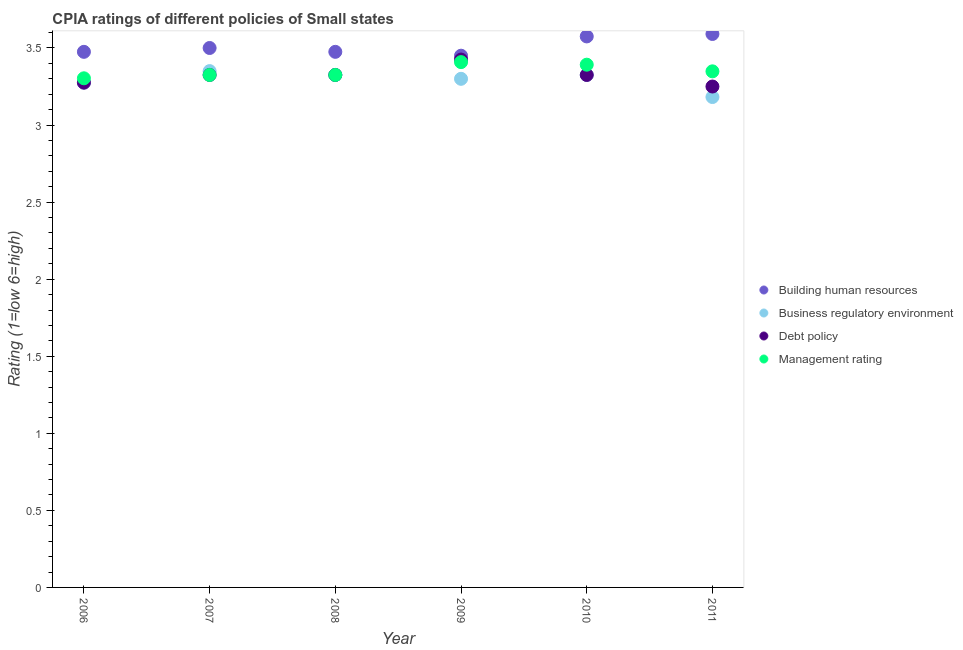How many different coloured dotlines are there?
Ensure brevity in your answer.  4. Across all years, what is the maximum cpia rating of building human resources?
Your answer should be very brief. 3.59. In which year was the cpia rating of business regulatory environment minimum?
Provide a short and direct response. 2011. What is the total cpia rating of debt policy in the graph?
Keep it short and to the point. 19.93. What is the difference between the cpia rating of debt policy in 2007 and that in 2011?
Provide a succinct answer. 0.08. What is the difference between the cpia rating of debt policy in 2010 and the cpia rating of management in 2006?
Give a very brief answer. 0.02. What is the average cpia rating of debt policy per year?
Keep it short and to the point. 3.32. In the year 2011, what is the difference between the cpia rating of business regulatory environment and cpia rating of management?
Keep it short and to the point. -0.17. What is the ratio of the cpia rating of debt policy in 2007 to that in 2011?
Your response must be concise. 1.02. Is the cpia rating of business regulatory environment in 2008 less than that in 2011?
Your answer should be very brief. No. Is the difference between the cpia rating of building human resources in 2009 and 2010 greater than the difference between the cpia rating of management in 2009 and 2010?
Make the answer very short. No. What is the difference between the highest and the second highest cpia rating of business regulatory environment?
Your response must be concise. 0.02. What is the difference between the highest and the lowest cpia rating of business regulatory environment?
Give a very brief answer. 0.17. Is it the case that in every year, the sum of the cpia rating of building human resources and cpia rating of debt policy is greater than the sum of cpia rating of business regulatory environment and cpia rating of management?
Ensure brevity in your answer.  No. Is it the case that in every year, the sum of the cpia rating of building human resources and cpia rating of business regulatory environment is greater than the cpia rating of debt policy?
Your response must be concise. Yes. Is the cpia rating of business regulatory environment strictly greater than the cpia rating of management over the years?
Provide a succinct answer. No. Is the cpia rating of building human resources strictly less than the cpia rating of management over the years?
Provide a succinct answer. No. Are the values on the major ticks of Y-axis written in scientific E-notation?
Your answer should be very brief. No. Does the graph contain any zero values?
Your answer should be very brief. No. How many legend labels are there?
Your answer should be compact. 4. How are the legend labels stacked?
Offer a terse response. Vertical. What is the title of the graph?
Ensure brevity in your answer.  CPIA ratings of different policies of Small states. Does "Secondary vocational education" appear as one of the legend labels in the graph?
Your response must be concise. No. What is the Rating (1=low 6=high) of Building human resources in 2006?
Ensure brevity in your answer.  3.48. What is the Rating (1=low 6=high) of Business regulatory environment in 2006?
Your answer should be compact. 3.27. What is the Rating (1=low 6=high) of Debt policy in 2006?
Your response must be concise. 3.27. What is the Rating (1=low 6=high) in Management rating in 2006?
Give a very brief answer. 3.3. What is the Rating (1=low 6=high) of Building human resources in 2007?
Offer a very short reply. 3.5. What is the Rating (1=low 6=high) of Business regulatory environment in 2007?
Ensure brevity in your answer.  3.35. What is the Rating (1=low 6=high) in Debt policy in 2007?
Your answer should be compact. 3.33. What is the Rating (1=low 6=high) of Management rating in 2007?
Make the answer very short. 3.33. What is the Rating (1=low 6=high) of Building human resources in 2008?
Make the answer very short. 3.48. What is the Rating (1=low 6=high) of Business regulatory environment in 2008?
Make the answer very short. 3.33. What is the Rating (1=low 6=high) of Debt policy in 2008?
Keep it short and to the point. 3.33. What is the Rating (1=low 6=high) of Management rating in 2008?
Your answer should be compact. 3.33. What is the Rating (1=low 6=high) in Building human resources in 2009?
Offer a very short reply. 3.45. What is the Rating (1=low 6=high) of Debt policy in 2009?
Offer a terse response. 3.42. What is the Rating (1=low 6=high) in Management rating in 2009?
Ensure brevity in your answer.  3.41. What is the Rating (1=low 6=high) of Building human resources in 2010?
Your answer should be very brief. 3.58. What is the Rating (1=low 6=high) of Business regulatory environment in 2010?
Keep it short and to the point. 3.33. What is the Rating (1=low 6=high) in Debt policy in 2010?
Your response must be concise. 3.33. What is the Rating (1=low 6=high) of Management rating in 2010?
Your answer should be compact. 3.39. What is the Rating (1=low 6=high) in Building human resources in 2011?
Ensure brevity in your answer.  3.59. What is the Rating (1=low 6=high) in Business regulatory environment in 2011?
Your answer should be very brief. 3.18. What is the Rating (1=low 6=high) of Debt policy in 2011?
Offer a terse response. 3.25. What is the Rating (1=low 6=high) in Management rating in 2011?
Keep it short and to the point. 3.35. Across all years, what is the maximum Rating (1=low 6=high) in Building human resources?
Provide a succinct answer. 3.59. Across all years, what is the maximum Rating (1=low 6=high) of Business regulatory environment?
Make the answer very short. 3.35. Across all years, what is the maximum Rating (1=low 6=high) in Debt policy?
Offer a terse response. 3.42. Across all years, what is the maximum Rating (1=low 6=high) of Management rating?
Provide a succinct answer. 3.41. Across all years, what is the minimum Rating (1=low 6=high) of Building human resources?
Make the answer very short. 3.45. Across all years, what is the minimum Rating (1=low 6=high) in Business regulatory environment?
Ensure brevity in your answer.  3.18. Across all years, what is the minimum Rating (1=low 6=high) in Debt policy?
Provide a succinct answer. 3.25. Across all years, what is the minimum Rating (1=low 6=high) in Management rating?
Keep it short and to the point. 3.3. What is the total Rating (1=low 6=high) of Building human resources in the graph?
Offer a very short reply. 21.07. What is the total Rating (1=low 6=high) of Business regulatory environment in the graph?
Keep it short and to the point. 19.76. What is the total Rating (1=low 6=high) in Debt policy in the graph?
Make the answer very short. 19.93. What is the total Rating (1=low 6=high) in Management rating in the graph?
Provide a short and direct response. 20.1. What is the difference between the Rating (1=low 6=high) in Building human resources in 2006 and that in 2007?
Provide a succinct answer. -0.03. What is the difference between the Rating (1=low 6=high) in Business regulatory environment in 2006 and that in 2007?
Give a very brief answer. -0.07. What is the difference between the Rating (1=low 6=high) of Management rating in 2006 and that in 2007?
Your answer should be compact. -0.02. What is the difference between the Rating (1=low 6=high) in Building human resources in 2006 and that in 2008?
Make the answer very short. 0. What is the difference between the Rating (1=low 6=high) of Debt policy in 2006 and that in 2008?
Offer a very short reply. -0.05. What is the difference between the Rating (1=low 6=high) in Management rating in 2006 and that in 2008?
Your response must be concise. -0.02. What is the difference between the Rating (1=low 6=high) of Building human resources in 2006 and that in 2009?
Keep it short and to the point. 0.03. What is the difference between the Rating (1=low 6=high) of Business regulatory environment in 2006 and that in 2009?
Give a very brief answer. -0.03. What is the difference between the Rating (1=low 6=high) in Management rating in 2006 and that in 2009?
Give a very brief answer. -0.1. What is the difference between the Rating (1=low 6=high) of Building human resources in 2006 and that in 2010?
Offer a terse response. -0.1. What is the difference between the Rating (1=low 6=high) in Business regulatory environment in 2006 and that in 2010?
Offer a very short reply. -0.05. What is the difference between the Rating (1=low 6=high) of Debt policy in 2006 and that in 2010?
Ensure brevity in your answer.  -0.05. What is the difference between the Rating (1=low 6=high) in Management rating in 2006 and that in 2010?
Offer a terse response. -0.09. What is the difference between the Rating (1=low 6=high) in Building human resources in 2006 and that in 2011?
Keep it short and to the point. -0.12. What is the difference between the Rating (1=low 6=high) of Business regulatory environment in 2006 and that in 2011?
Offer a very short reply. 0.09. What is the difference between the Rating (1=low 6=high) of Debt policy in 2006 and that in 2011?
Your answer should be very brief. 0.03. What is the difference between the Rating (1=low 6=high) in Management rating in 2006 and that in 2011?
Ensure brevity in your answer.  -0.05. What is the difference between the Rating (1=low 6=high) in Building human resources in 2007 and that in 2008?
Give a very brief answer. 0.03. What is the difference between the Rating (1=low 6=high) of Business regulatory environment in 2007 and that in 2008?
Keep it short and to the point. 0.03. What is the difference between the Rating (1=low 6=high) in Debt policy in 2007 and that in 2008?
Your answer should be very brief. 0. What is the difference between the Rating (1=low 6=high) of Business regulatory environment in 2007 and that in 2009?
Ensure brevity in your answer.  0.05. What is the difference between the Rating (1=low 6=high) of Management rating in 2007 and that in 2009?
Make the answer very short. -0.08. What is the difference between the Rating (1=low 6=high) of Building human resources in 2007 and that in 2010?
Offer a terse response. -0.07. What is the difference between the Rating (1=low 6=high) in Business regulatory environment in 2007 and that in 2010?
Make the answer very short. 0.03. What is the difference between the Rating (1=low 6=high) of Debt policy in 2007 and that in 2010?
Provide a short and direct response. 0. What is the difference between the Rating (1=low 6=high) of Management rating in 2007 and that in 2010?
Ensure brevity in your answer.  -0.07. What is the difference between the Rating (1=low 6=high) of Building human resources in 2007 and that in 2011?
Make the answer very short. -0.09. What is the difference between the Rating (1=low 6=high) of Business regulatory environment in 2007 and that in 2011?
Give a very brief answer. 0.17. What is the difference between the Rating (1=low 6=high) in Debt policy in 2007 and that in 2011?
Your answer should be compact. 0.07. What is the difference between the Rating (1=low 6=high) in Management rating in 2007 and that in 2011?
Make the answer very short. -0.02. What is the difference between the Rating (1=low 6=high) of Building human resources in 2008 and that in 2009?
Offer a terse response. 0.03. What is the difference between the Rating (1=low 6=high) in Business regulatory environment in 2008 and that in 2009?
Your response must be concise. 0.03. What is the difference between the Rating (1=low 6=high) of Management rating in 2008 and that in 2009?
Keep it short and to the point. -0.08. What is the difference between the Rating (1=low 6=high) in Business regulatory environment in 2008 and that in 2010?
Your response must be concise. 0. What is the difference between the Rating (1=low 6=high) of Debt policy in 2008 and that in 2010?
Offer a very short reply. 0. What is the difference between the Rating (1=low 6=high) in Management rating in 2008 and that in 2010?
Offer a terse response. -0.07. What is the difference between the Rating (1=low 6=high) of Building human resources in 2008 and that in 2011?
Ensure brevity in your answer.  -0.12. What is the difference between the Rating (1=low 6=high) in Business regulatory environment in 2008 and that in 2011?
Keep it short and to the point. 0.14. What is the difference between the Rating (1=low 6=high) in Debt policy in 2008 and that in 2011?
Your answer should be very brief. 0.07. What is the difference between the Rating (1=low 6=high) in Management rating in 2008 and that in 2011?
Make the answer very short. -0.02. What is the difference between the Rating (1=low 6=high) in Building human resources in 2009 and that in 2010?
Your response must be concise. -0.12. What is the difference between the Rating (1=low 6=high) of Business regulatory environment in 2009 and that in 2010?
Give a very brief answer. -0.03. What is the difference between the Rating (1=low 6=high) in Debt policy in 2009 and that in 2010?
Provide a short and direct response. 0.1. What is the difference between the Rating (1=low 6=high) of Management rating in 2009 and that in 2010?
Provide a succinct answer. 0.02. What is the difference between the Rating (1=low 6=high) in Building human resources in 2009 and that in 2011?
Your answer should be very brief. -0.14. What is the difference between the Rating (1=low 6=high) of Business regulatory environment in 2009 and that in 2011?
Provide a short and direct response. 0.12. What is the difference between the Rating (1=low 6=high) of Debt policy in 2009 and that in 2011?
Make the answer very short. 0.17. What is the difference between the Rating (1=low 6=high) in Management rating in 2009 and that in 2011?
Ensure brevity in your answer.  0.06. What is the difference between the Rating (1=low 6=high) of Building human resources in 2010 and that in 2011?
Offer a very short reply. -0.02. What is the difference between the Rating (1=low 6=high) of Business regulatory environment in 2010 and that in 2011?
Make the answer very short. 0.14. What is the difference between the Rating (1=low 6=high) of Debt policy in 2010 and that in 2011?
Give a very brief answer. 0.07. What is the difference between the Rating (1=low 6=high) in Management rating in 2010 and that in 2011?
Your answer should be very brief. 0.04. What is the difference between the Rating (1=low 6=high) of Building human resources in 2006 and the Rating (1=low 6=high) of Debt policy in 2007?
Provide a succinct answer. 0.15. What is the difference between the Rating (1=low 6=high) of Business regulatory environment in 2006 and the Rating (1=low 6=high) of Debt policy in 2007?
Your answer should be compact. -0.05. What is the difference between the Rating (1=low 6=high) of Business regulatory environment in 2006 and the Rating (1=low 6=high) of Management rating in 2007?
Provide a short and direct response. -0.05. What is the difference between the Rating (1=low 6=high) in Building human resources in 2006 and the Rating (1=low 6=high) in Debt policy in 2008?
Give a very brief answer. 0.15. What is the difference between the Rating (1=low 6=high) in Business regulatory environment in 2006 and the Rating (1=low 6=high) in Debt policy in 2008?
Your response must be concise. -0.05. What is the difference between the Rating (1=low 6=high) in Business regulatory environment in 2006 and the Rating (1=low 6=high) in Management rating in 2008?
Offer a terse response. -0.05. What is the difference between the Rating (1=low 6=high) of Building human resources in 2006 and the Rating (1=low 6=high) of Business regulatory environment in 2009?
Offer a very short reply. 0.17. What is the difference between the Rating (1=low 6=high) in Building human resources in 2006 and the Rating (1=low 6=high) in Management rating in 2009?
Keep it short and to the point. 0.07. What is the difference between the Rating (1=low 6=high) of Business regulatory environment in 2006 and the Rating (1=low 6=high) of Management rating in 2009?
Your answer should be very brief. -0.13. What is the difference between the Rating (1=low 6=high) of Debt policy in 2006 and the Rating (1=low 6=high) of Management rating in 2009?
Provide a short and direct response. -0.13. What is the difference between the Rating (1=low 6=high) of Building human resources in 2006 and the Rating (1=low 6=high) of Management rating in 2010?
Keep it short and to the point. 0.08. What is the difference between the Rating (1=low 6=high) in Business regulatory environment in 2006 and the Rating (1=low 6=high) in Management rating in 2010?
Your answer should be compact. -0.12. What is the difference between the Rating (1=low 6=high) in Debt policy in 2006 and the Rating (1=low 6=high) in Management rating in 2010?
Give a very brief answer. -0.12. What is the difference between the Rating (1=low 6=high) of Building human resources in 2006 and the Rating (1=low 6=high) of Business regulatory environment in 2011?
Give a very brief answer. 0.29. What is the difference between the Rating (1=low 6=high) of Building human resources in 2006 and the Rating (1=low 6=high) of Debt policy in 2011?
Your answer should be very brief. 0.23. What is the difference between the Rating (1=low 6=high) of Building human resources in 2006 and the Rating (1=low 6=high) of Management rating in 2011?
Offer a terse response. 0.13. What is the difference between the Rating (1=low 6=high) of Business regulatory environment in 2006 and the Rating (1=low 6=high) of Debt policy in 2011?
Provide a short and direct response. 0.03. What is the difference between the Rating (1=low 6=high) of Business regulatory environment in 2006 and the Rating (1=low 6=high) of Management rating in 2011?
Offer a very short reply. -0.07. What is the difference between the Rating (1=low 6=high) in Debt policy in 2006 and the Rating (1=low 6=high) in Management rating in 2011?
Provide a short and direct response. -0.07. What is the difference between the Rating (1=low 6=high) of Building human resources in 2007 and the Rating (1=low 6=high) of Business regulatory environment in 2008?
Offer a terse response. 0.17. What is the difference between the Rating (1=low 6=high) of Building human resources in 2007 and the Rating (1=low 6=high) of Debt policy in 2008?
Ensure brevity in your answer.  0.17. What is the difference between the Rating (1=low 6=high) in Building human resources in 2007 and the Rating (1=low 6=high) in Management rating in 2008?
Keep it short and to the point. 0.17. What is the difference between the Rating (1=low 6=high) in Business regulatory environment in 2007 and the Rating (1=low 6=high) in Debt policy in 2008?
Provide a succinct answer. 0.03. What is the difference between the Rating (1=low 6=high) in Business regulatory environment in 2007 and the Rating (1=low 6=high) in Management rating in 2008?
Your answer should be very brief. 0.03. What is the difference between the Rating (1=low 6=high) in Building human resources in 2007 and the Rating (1=low 6=high) in Business regulatory environment in 2009?
Offer a very short reply. 0.2. What is the difference between the Rating (1=low 6=high) of Building human resources in 2007 and the Rating (1=low 6=high) of Debt policy in 2009?
Offer a terse response. 0.07. What is the difference between the Rating (1=low 6=high) of Building human resources in 2007 and the Rating (1=low 6=high) of Management rating in 2009?
Offer a very short reply. 0.09. What is the difference between the Rating (1=low 6=high) in Business regulatory environment in 2007 and the Rating (1=low 6=high) in Debt policy in 2009?
Give a very brief answer. -0.07. What is the difference between the Rating (1=low 6=high) of Business regulatory environment in 2007 and the Rating (1=low 6=high) of Management rating in 2009?
Provide a succinct answer. -0.06. What is the difference between the Rating (1=low 6=high) in Debt policy in 2007 and the Rating (1=low 6=high) in Management rating in 2009?
Provide a short and direct response. -0.08. What is the difference between the Rating (1=low 6=high) of Building human resources in 2007 and the Rating (1=low 6=high) of Business regulatory environment in 2010?
Keep it short and to the point. 0.17. What is the difference between the Rating (1=low 6=high) of Building human resources in 2007 and the Rating (1=low 6=high) of Debt policy in 2010?
Your answer should be very brief. 0.17. What is the difference between the Rating (1=low 6=high) in Building human resources in 2007 and the Rating (1=low 6=high) in Management rating in 2010?
Provide a succinct answer. 0.11. What is the difference between the Rating (1=low 6=high) in Business regulatory environment in 2007 and the Rating (1=low 6=high) in Debt policy in 2010?
Provide a short and direct response. 0.03. What is the difference between the Rating (1=low 6=high) in Business regulatory environment in 2007 and the Rating (1=low 6=high) in Management rating in 2010?
Offer a terse response. -0.04. What is the difference between the Rating (1=low 6=high) in Debt policy in 2007 and the Rating (1=low 6=high) in Management rating in 2010?
Ensure brevity in your answer.  -0.07. What is the difference between the Rating (1=low 6=high) of Building human resources in 2007 and the Rating (1=low 6=high) of Business regulatory environment in 2011?
Your answer should be very brief. 0.32. What is the difference between the Rating (1=low 6=high) in Building human resources in 2007 and the Rating (1=low 6=high) in Management rating in 2011?
Keep it short and to the point. 0.15. What is the difference between the Rating (1=low 6=high) of Business regulatory environment in 2007 and the Rating (1=low 6=high) of Debt policy in 2011?
Give a very brief answer. 0.1. What is the difference between the Rating (1=low 6=high) of Business regulatory environment in 2007 and the Rating (1=low 6=high) of Management rating in 2011?
Your answer should be very brief. 0. What is the difference between the Rating (1=low 6=high) of Debt policy in 2007 and the Rating (1=low 6=high) of Management rating in 2011?
Provide a short and direct response. -0.02. What is the difference between the Rating (1=low 6=high) in Building human resources in 2008 and the Rating (1=low 6=high) in Business regulatory environment in 2009?
Keep it short and to the point. 0.17. What is the difference between the Rating (1=low 6=high) of Building human resources in 2008 and the Rating (1=low 6=high) of Debt policy in 2009?
Offer a terse response. 0.05. What is the difference between the Rating (1=low 6=high) in Building human resources in 2008 and the Rating (1=low 6=high) in Management rating in 2009?
Offer a very short reply. 0.07. What is the difference between the Rating (1=low 6=high) in Business regulatory environment in 2008 and the Rating (1=low 6=high) in Management rating in 2009?
Ensure brevity in your answer.  -0.08. What is the difference between the Rating (1=low 6=high) in Debt policy in 2008 and the Rating (1=low 6=high) in Management rating in 2009?
Your response must be concise. -0.08. What is the difference between the Rating (1=low 6=high) of Building human resources in 2008 and the Rating (1=low 6=high) of Business regulatory environment in 2010?
Provide a short and direct response. 0.15. What is the difference between the Rating (1=low 6=high) of Building human resources in 2008 and the Rating (1=low 6=high) of Debt policy in 2010?
Provide a short and direct response. 0.15. What is the difference between the Rating (1=low 6=high) of Building human resources in 2008 and the Rating (1=low 6=high) of Management rating in 2010?
Provide a short and direct response. 0.08. What is the difference between the Rating (1=low 6=high) of Business regulatory environment in 2008 and the Rating (1=low 6=high) of Debt policy in 2010?
Keep it short and to the point. 0. What is the difference between the Rating (1=low 6=high) in Business regulatory environment in 2008 and the Rating (1=low 6=high) in Management rating in 2010?
Give a very brief answer. -0.07. What is the difference between the Rating (1=low 6=high) of Debt policy in 2008 and the Rating (1=low 6=high) of Management rating in 2010?
Give a very brief answer. -0.07. What is the difference between the Rating (1=low 6=high) in Building human resources in 2008 and the Rating (1=low 6=high) in Business regulatory environment in 2011?
Offer a terse response. 0.29. What is the difference between the Rating (1=low 6=high) of Building human resources in 2008 and the Rating (1=low 6=high) of Debt policy in 2011?
Ensure brevity in your answer.  0.23. What is the difference between the Rating (1=low 6=high) of Building human resources in 2008 and the Rating (1=low 6=high) of Management rating in 2011?
Your answer should be compact. 0.13. What is the difference between the Rating (1=low 6=high) of Business regulatory environment in 2008 and the Rating (1=low 6=high) of Debt policy in 2011?
Provide a short and direct response. 0.07. What is the difference between the Rating (1=low 6=high) of Business regulatory environment in 2008 and the Rating (1=low 6=high) of Management rating in 2011?
Make the answer very short. -0.02. What is the difference between the Rating (1=low 6=high) of Debt policy in 2008 and the Rating (1=low 6=high) of Management rating in 2011?
Your answer should be compact. -0.02. What is the difference between the Rating (1=low 6=high) of Building human resources in 2009 and the Rating (1=low 6=high) of Debt policy in 2010?
Your response must be concise. 0.12. What is the difference between the Rating (1=low 6=high) in Building human resources in 2009 and the Rating (1=low 6=high) in Management rating in 2010?
Your answer should be very brief. 0.06. What is the difference between the Rating (1=low 6=high) of Business regulatory environment in 2009 and the Rating (1=low 6=high) of Debt policy in 2010?
Ensure brevity in your answer.  -0.03. What is the difference between the Rating (1=low 6=high) of Business regulatory environment in 2009 and the Rating (1=low 6=high) of Management rating in 2010?
Your response must be concise. -0.09. What is the difference between the Rating (1=low 6=high) in Debt policy in 2009 and the Rating (1=low 6=high) in Management rating in 2010?
Provide a succinct answer. 0.03. What is the difference between the Rating (1=low 6=high) of Building human resources in 2009 and the Rating (1=low 6=high) of Business regulatory environment in 2011?
Provide a succinct answer. 0.27. What is the difference between the Rating (1=low 6=high) of Building human resources in 2009 and the Rating (1=low 6=high) of Debt policy in 2011?
Give a very brief answer. 0.2. What is the difference between the Rating (1=low 6=high) in Building human resources in 2009 and the Rating (1=low 6=high) in Management rating in 2011?
Offer a very short reply. 0.1. What is the difference between the Rating (1=low 6=high) of Business regulatory environment in 2009 and the Rating (1=low 6=high) of Management rating in 2011?
Make the answer very short. -0.05. What is the difference between the Rating (1=low 6=high) of Debt policy in 2009 and the Rating (1=low 6=high) of Management rating in 2011?
Ensure brevity in your answer.  0.08. What is the difference between the Rating (1=low 6=high) in Building human resources in 2010 and the Rating (1=low 6=high) in Business regulatory environment in 2011?
Provide a succinct answer. 0.39. What is the difference between the Rating (1=low 6=high) in Building human resources in 2010 and the Rating (1=low 6=high) in Debt policy in 2011?
Ensure brevity in your answer.  0.33. What is the difference between the Rating (1=low 6=high) in Building human resources in 2010 and the Rating (1=low 6=high) in Management rating in 2011?
Offer a very short reply. 0.23. What is the difference between the Rating (1=low 6=high) in Business regulatory environment in 2010 and the Rating (1=low 6=high) in Debt policy in 2011?
Give a very brief answer. 0.07. What is the difference between the Rating (1=low 6=high) of Business regulatory environment in 2010 and the Rating (1=low 6=high) of Management rating in 2011?
Your response must be concise. -0.02. What is the difference between the Rating (1=low 6=high) of Debt policy in 2010 and the Rating (1=low 6=high) of Management rating in 2011?
Provide a succinct answer. -0.02. What is the average Rating (1=low 6=high) in Building human resources per year?
Offer a very short reply. 3.51. What is the average Rating (1=low 6=high) of Business regulatory environment per year?
Make the answer very short. 3.29. What is the average Rating (1=low 6=high) of Debt policy per year?
Your answer should be very brief. 3.32. What is the average Rating (1=low 6=high) of Management rating per year?
Offer a terse response. 3.35. In the year 2006, what is the difference between the Rating (1=low 6=high) in Building human resources and Rating (1=low 6=high) in Business regulatory environment?
Your response must be concise. 0.2. In the year 2006, what is the difference between the Rating (1=low 6=high) of Building human resources and Rating (1=low 6=high) of Debt policy?
Offer a terse response. 0.2. In the year 2006, what is the difference between the Rating (1=low 6=high) of Building human resources and Rating (1=low 6=high) of Management rating?
Give a very brief answer. 0.17. In the year 2006, what is the difference between the Rating (1=low 6=high) of Business regulatory environment and Rating (1=low 6=high) of Management rating?
Offer a very short reply. -0.03. In the year 2006, what is the difference between the Rating (1=low 6=high) of Debt policy and Rating (1=low 6=high) of Management rating?
Offer a very short reply. -0.03. In the year 2007, what is the difference between the Rating (1=low 6=high) in Building human resources and Rating (1=low 6=high) in Business regulatory environment?
Your answer should be compact. 0.15. In the year 2007, what is the difference between the Rating (1=low 6=high) in Building human resources and Rating (1=low 6=high) in Debt policy?
Make the answer very short. 0.17. In the year 2007, what is the difference between the Rating (1=low 6=high) of Building human resources and Rating (1=low 6=high) of Management rating?
Make the answer very short. 0.17. In the year 2007, what is the difference between the Rating (1=low 6=high) of Business regulatory environment and Rating (1=low 6=high) of Debt policy?
Provide a succinct answer. 0.03. In the year 2007, what is the difference between the Rating (1=low 6=high) of Business regulatory environment and Rating (1=low 6=high) of Management rating?
Ensure brevity in your answer.  0.03. In the year 2007, what is the difference between the Rating (1=low 6=high) of Debt policy and Rating (1=low 6=high) of Management rating?
Your answer should be very brief. 0. In the year 2008, what is the difference between the Rating (1=low 6=high) of Building human resources and Rating (1=low 6=high) of Debt policy?
Your response must be concise. 0.15. In the year 2008, what is the difference between the Rating (1=low 6=high) of Building human resources and Rating (1=low 6=high) of Management rating?
Provide a succinct answer. 0.15. In the year 2008, what is the difference between the Rating (1=low 6=high) of Debt policy and Rating (1=low 6=high) of Management rating?
Offer a terse response. 0. In the year 2009, what is the difference between the Rating (1=low 6=high) in Building human resources and Rating (1=low 6=high) in Debt policy?
Provide a short and direct response. 0.03. In the year 2009, what is the difference between the Rating (1=low 6=high) of Building human resources and Rating (1=low 6=high) of Management rating?
Your response must be concise. 0.04. In the year 2009, what is the difference between the Rating (1=low 6=high) of Business regulatory environment and Rating (1=low 6=high) of Debt policy?
Provide a succinct answer. -0.12. In the year 2009, what is the difference between the Rating (1=low 6=high) of Business regulatory environment and Rating (1=low 6=high) of Management rating?
Your answer should be very brief. -0.11. In the year 2009, what is the difference between the Rating (1=low 6=high) in Debt policy and Rating (1=low 6=high) in Management rating?
Ensure brevity in your answer.  0.02. In the year 2010, what is the difference between the Rating (1=low 6=high) in Building human resources and Rating (1=low 6=high) in Debt policy?
Offer a very short reply. 0.25. In the year 2010, what is the difference between the Rating (1=low 6=high) of Building human resources and Rating (1=low 6=high) of Management rating?
Offer a terse response. 0.18. In the year 2010, what is the difference between the Rating (1=low 6=high) in Business regulatory environment and Rating (1=low 6=high) in Management rating?
Offer a very short reply. -0.07. In the year 2010, what is the difference between the Rating (1=low 6=high) in Debt policy and Rating (1=low 6=high) in Management rating?
Keep it short and to the point. -0.07. In the year 2011, what is the difference between the Rating (1=low 6=high) of Building human resources and Rating (1=low 6=high) of Business regulatory environment?
Your response must be concise. 0.41. In the year 2011, what is the difference between the Rating (1=low 6=high) in Building human resources and Rating (1=low 6=high) in Debt policy?
Your answer should be compact. 0.34. In the year 2011, what is the difference between the Rating (1=low 6=high) of Building human resources and Rating (1=low 6=high) of Management rating?
Keep it short and to the point. 0.24. In the year 2011, what is the difference between the Rating (1=low 6=high) in Business regulatory environment and Rating (1=low 6=high) in Debt policy?
Your response must be concise. -0.07. In the year 2011, what is the difference between the Rating (1=low 6=high) of Debt policy and Rating (1=low 6=high) of Management rating?
Make the answer very short. -0.1. What is the ratio of the Rating (1=low 6=high) of Building human resources in 2006 to that in 2007?
Your answer should be very brief. 0.99. What is the ratio of the Rating (1=low 6=high) of Business regulatory environment in 2006 to that in 2007?
Make the answer very short. 0.98. What is the ratio of the Rating (1=low 6=high) of Debt policy in 2006 to that in 2007?
Provide a short and direct response. 0.98. What is the ratio of the Rating (1=low 6=high) of Management rating in 2006 to that in 2007?
Your answer should be compact. 0.99. What is the ratio of the Rating (1=low 6=high) in Building human resources in 2006 to that in 2008?
Provide a short and direct response. 1. What is the ratio of the Rating (1=low 6=high) of Debt policy in 2006 to that in 2008?
Provide a succinct answer. 0.98. What is the ratio of the Rating (1=low 6=high) of Management rating in 2006 to that in 2008?
Offer a very short reply. 0.99. What is the ratio of the Rating (1=low 6=high) of Building human resources in 2006 to that in 2009?
Ensure brevity in your answer.  1.01. What is the ratio of the Rating (1=low 6=high) of Debt policy in 2006 to that in 2009?
Your answer should be compact. 0.96. What is the ratio of the Rating (1=low 6=high) in Management rating in 2006 to that in 2009?
Give a very brief answer. 0.97. What is the ratio of the Rating (1=low 6=high) of Building human resources in 2006 to that in 2010?
Keep it short and to the point. 0.97. What is the ratio of the Rating (1=low 6=high) in Debt policy in 2006 to that in 2010?
Make the answer very short. 0.98. What is the ratio of the Rating (1=low 6=high) of Management rating in 2006 to that in 2010?
Offer a very short reply. 0.97. What is the ratio of the Rating (1=low 6=high) in Business regulatory environment in 2006 to that in 2011?
Keep it short and to the point. 1.03. What is the ratio of the Rating (1=low 6=high) in Debt policy in 2006 to that in 2011?
Offer a terse response. 1.01. What is the ratio of the Rating (1=low 6=high) in Management rating in 2006 to that in 2011?
Your answer should be compact. 0.99. What is the ratio of the Rating (1=low 6=high) of Business regulatory environment in 2007 to that in 2008?
Keep it short and to the point. 1.01. What is the ratio of the Rating (1=low 6=high) in Debt policy in 2007 to that in 2008?
Make the answer very short. 1. What is the ratio of the Rating (1=low 6=high) of Management rating in 2007 to that in 2008?
Provide a succinct answer. 1. What is the ratio of the Rating (1=low 6=high) in Building human resources in 2007 to that in 2009?
Provide a succinct answer. 1.01. What is the ratio of the Rating (1=low 6=high) of Business regulatory environment in 2007 to that in 2009?
Provide a succinct answer. 1.02. What is the ratio of the Rating (1=low 6=high) in Debt policy in 2007 to that in 2009?
Provide a succinct answer. 0.97. What is the ratio of the Rating (1=low 6=high) in Management rating in 2007 to that in 2009?
Provide a short and direct response. 0.98. What is the ratio of the Rating (1=low 6=high) in Building human resources in 2007 to that in 2010?
Provide a short and direct response. 0.98. What is the ratio of the Rating (1=low 6=high) in Business regulatory environment in 2007 to that in 2010?
Give a very brief answer. 1.01. What is the ratio of the Rating (1=low 6=high) of Debt policy in 2007 to that in 2010?
Your answer should be very brief. 1. What is the ratio of the Rating (1=low 6=high) in Management rating in 2007 to that in 2010?
Keep it short and to the point. 0.98. What is the ratio of the Rating (1=low 6=high) of Building human resources in 2007 to that in 2011?
Make the answer very short. 0.97. What is the ratio of the Rating (1=low 6=high) in Business regulatory environment in 2007 to that in 2011?
Make the answer very short. 1.05. What is the ratio of the Rating (1=low 6=high) in Debt policy in 2007 to that in 2011?
Ensure brevity in your answer.  1.02. What is the ratio of the Rating (1=low 6=high) of Business regulatory environment in 2008 to that in 2009?
Make the answer very short. 1.01. What is the ratio of the Rating (1=low 6=high) of Debt policy in 2008 to that in 2009?
Keep it short and to the point. 0.97. What is the ratio of the Rating (1=low 6=high) in Management rating in 2008 to that in 2009?
Offer a terse response. 0.98. What is the ratio of the Rating (1=low 6=high) in Debt policy in 2008 to that in 2010?
Your answer should be compact. 1. What is the ratio of the Rating (1=low 6=high) in Management rating in 2008 to that in 2010?
Your response must be concise. 0.98. What is the ratio of the Rating (1=low 6=high) of Business regulatory environment in 2008 to that in 2011?
Provide a short and direct response. 1.04. What is the ratio of the Rating (1=low 6=high) of Debt policy in 2008 to that in 2011?
Offer a terse response. 1.02. What is the ratio of the Rating (1=low 6=high) of Building human resources in 2009 to that in 2010?
Offer a very short reply. 0.96. What is the ratio of the Rating (1=low 6=high) in Debt policy in 2009 to that in 2010?
Your answer should be compact. 1.03. What is the ratio of the Rating (1=low 6=high) of Management rating in 2009 to that in 2010?
Your answer should be compact. 1. What is the ratio of the Rating (1=low 6=high) in Building human resources in 2009 to that in 2011?
Your response must be concise. 0.96. What is the ratio of the Rating (1=low 6=high) of Business regulatory environment in 2009 to that in 2011?
Provide a short and direct response. 1.04. What is the ratio of the Rating (1=low 6=high) in Debt policy in 2009 to that in 2011?
Provide a short and direct response. 1.05. What is the ratio of the Rating (1=low 6=high) of Management rating in 2009 to that in 2011?
Your answer should be compact. 1.02. What is the ratio of the Rating (1=low 6=high) in Business regulatory environment in 2010 to that in 2011?
Offer a very short reply. 1.04. What is the ratio of the Rating (1=low 6=high) in Debt policy in 2010 to that in 2011?
Give a very brief answer. 1.02. What is the ratio of the Rating (1=low 6=high) of Management rating in 2010 to that in 2011?
Your response must be concise. 1.01. What is the difference between the highest and the second highest Rating (1=low 6=high) in Building human resources?
Make the answer very short. 0.02. What is the difference between the highest and the second highest Rating (1=low 6=high) of Business regulatory environment?
Provide a succinct answer. 0.03. What is the difference between the highest and the second highest Rating (1=low 6=high) of Debt policy?
Offer a very short reply. 0.1. What is the difference between the highest and the second highest Rating (1=low 6=high) of Management rating?
Your answer should be very brief. 0.02. What is the difference between the highest and the lowest Rating (1=low 6=high) of Building human resources?
Your answer should be compact. 0.14. What is the difference between the highest and the lowest Rating (1=low 6=high) in Business regulatory environment?
Your answer should be compact. 0.17. What is the difference between the highest and the lowest Rating (1=low 6=high) of Debt policy?
Your answer should be compact. 0.17. What is the difference between the highest and the lowest Rating (1=low 6=high) in Management rating?
Your response must be concise. 0.1. 